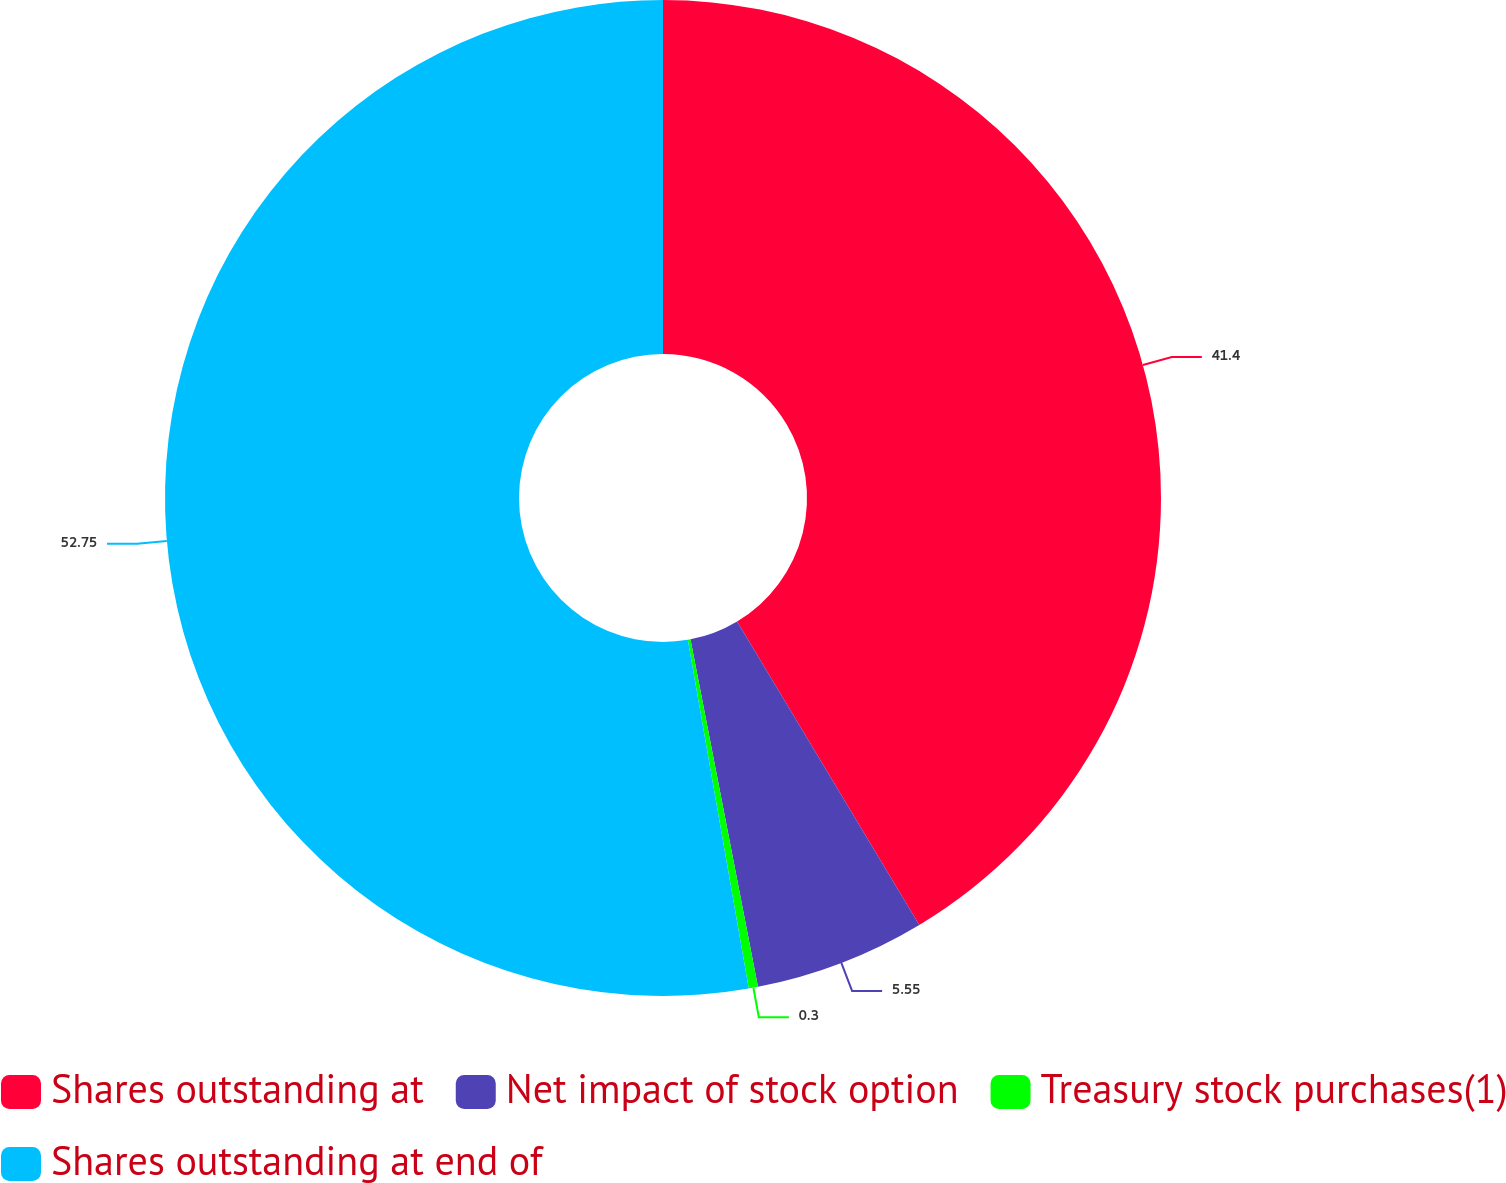Convert chart. <chart><loc_0><loc_0><loc_500><loc_500><pie_chart><fcel>Shares outstanding at<fcel>Net impact of stock option<fcel>Treasury stock purchases(1)<fcel>Shares outstanding at end of<nl><fcel>41.4%<fcel>5.55%<fcel>0.3%<fcel>52.76%<nl></chart> 